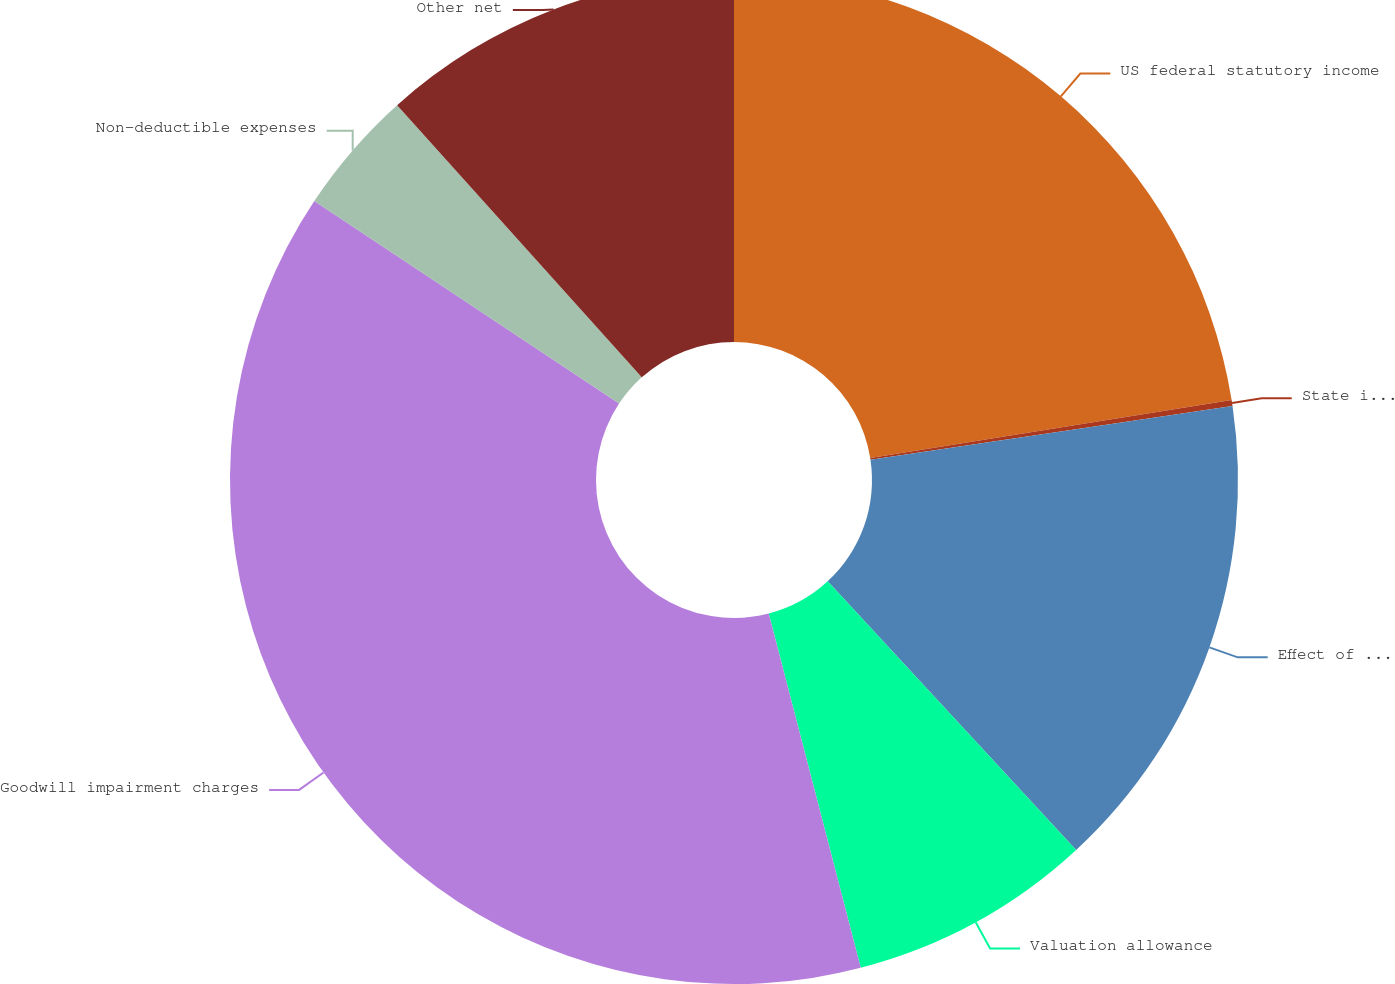<chart> <loc_0><loc_0><loc_500><loc_500><pie_chart><fcel>US federal statutory income<fcel>State income taxes net of<fcel>Effect of foreign taxes<fcel>Valuation allowance<fcel>Goodwill impairment charges<fcel>Non-deductible expenses<fcel>Other net<nl><fcel>22.46%<fcel>0.19%<fcel>15.47%<fcel>7.83%<fcel>38.38%<fcel>4.01%<fcel>11.65%<nl></chart> 